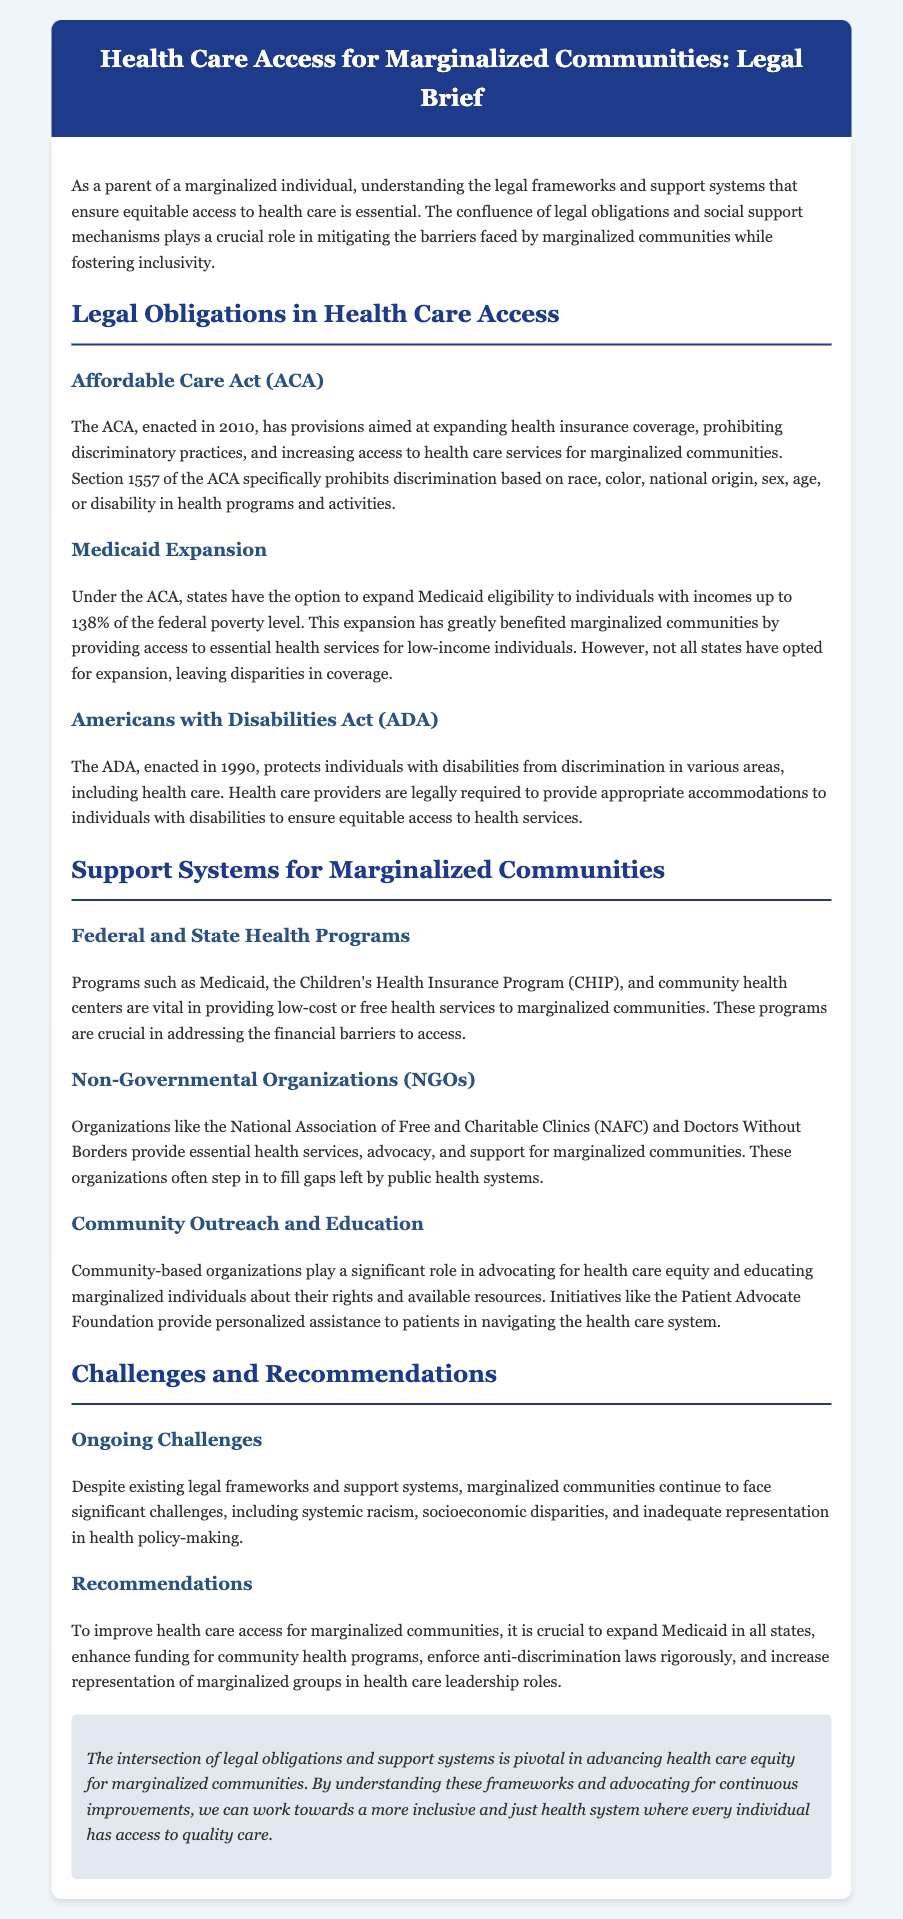What is the ACA? The ACA, enacted in 2010, has provisions aimed at expanding health insurance coverage and increasing access to health care services for marginalized communities.
Answer: ACA What does Section 1557 prohibit? Section 1557 of the ACA specifically prohibits discrimination based on race, color, national origin, sex, age, or disability in health programs and activities.
Answer: Discrimination What is a key benefit of Medicaid expansion? Medicaid expansion has greatly benefited marginalized communities by providing access to essential health services for low-income individuals.
Answer: Access Which organizations provide essential health services for marginalized communities? Organizations like the National Association of Free and Charitable Clinics (NAFC) and Doctors Without Borders provide essential health services and advocacy.
Answer: NAFC, Doctors Without Borders What are two programs mentioned that support marginalized communities? Programs such as Medicaid and the Children's Health Insurance Program (CHIP) are vital in providing low-cost or free health services to marginalized communities.
Answer: Medicaid, CHIP What ongoing challenge do marginalized communities face? Marginalized communities continue to face significant challenges, including systemic racism and socioeconomic disparities.
Answer: Systemic racism What is a recommendation to improve health care access? To improve health care access for marginalized communities, it is crucial to expand Medicaid in all states.
Answer: Expand Medicaid What role do community-based organizations play? Community-based organizations advocate for health care equity and educate marginalized individuals about their rights and available resources.
Answer: Advocacy What is the purpose of this legal brief? The intersection of legal obligations and support systems is pivotal in advancing health care equity for marginalized communities.
Answer: Advancing health care equity 